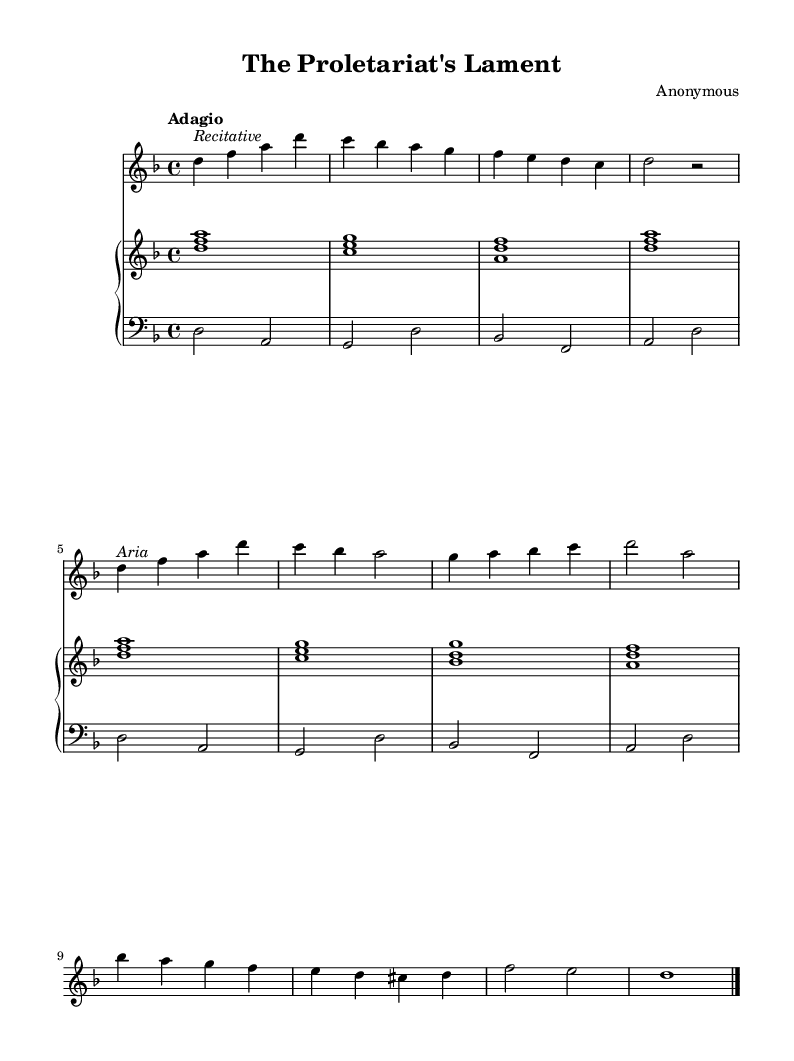What is the key signature of this music? The key signature is indicated at the beginning of the staff. Observing the music sheet reveals one flat (B), which corresponds to D minor.
Answer: D minor What is the time signature of this music? The time signature is located at the beginning of the staff, shown as 4/4. This means there are four beats in each measure, and the quarter note gets one beat.
Answer: 4/4 What is the tempo marking of this piece? The tempo marking is shown in the score, indicated by "Adagio". This suggests a slow tempo, typically between 66 to 76 beats per minute.
Answer: Adagio How many sections are in the soprano part? By examining the structure of the soprano part, it is evident that there are two distinct sections labeled "Recitative" and "Aria". This shows a division of the music into these two types of vocal expression.
Answer: Two What instruments are indicated in the score? The score specifies instruments under each staff with terms like "voice oohs" for the soprano and "harpsichord" for both hands in the piano. This means the soprano is accompanied by a harpsichord.
Answer: Voice and harpsichord What is the primary theme expressed in the lyrics? Analyzing the provided lyrics reveals a focus on themes of labor and oppression, reflecting a societal struggle and yearning for justice, clearly indicating a narrative of social inequality.
Answer: Class struggle Why is the piece classified as an opera? The work is classified as an opera due to its structural elements, including sung texts (lyrics), storytelling through music, and the dramatic exploration of social themes, which are characteristic of the operatic form.
Answer: Opera 